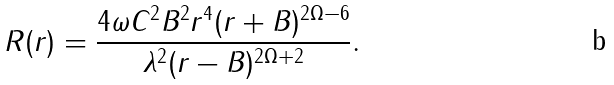<formula> <loc_0><loc_0><loc_500><loc_500>R ( r ) = \frac { 4 \omega C ^ { 2 } B ^ { 2 } r ^ { 4 } ( r + B ) ^ { 2 \Omega - 6 } } { \lambda ^ { 2 } ( r - B ) ^ { 2 \Omega + 2 } } .</formula> 